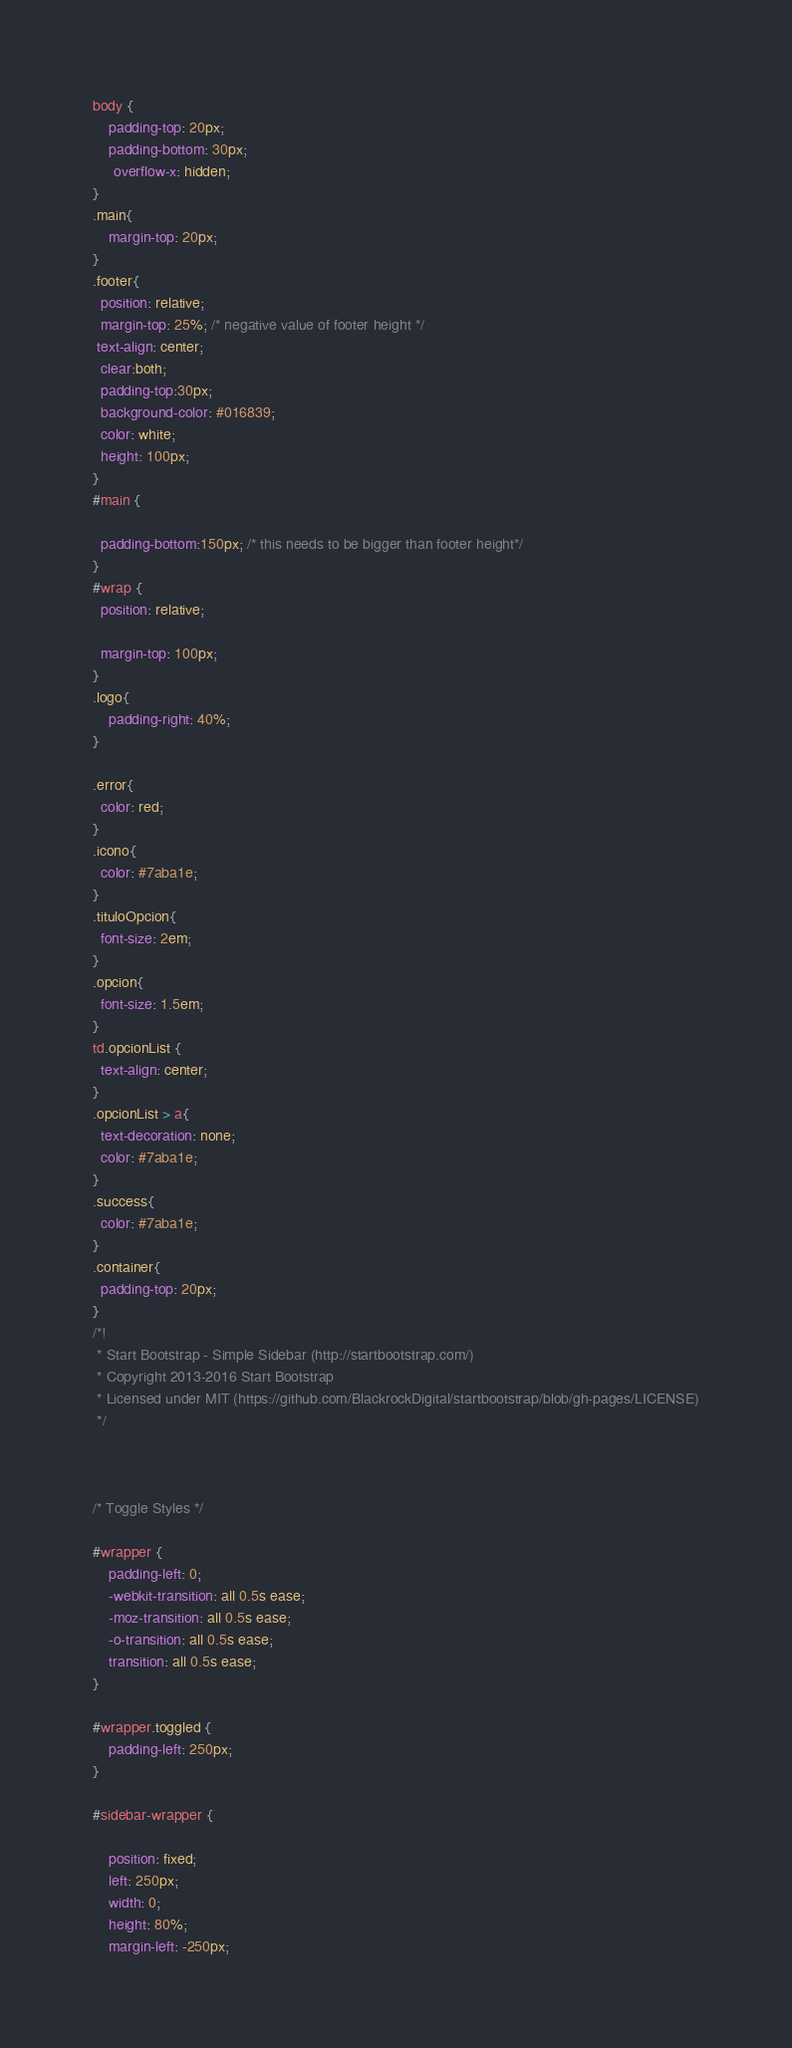<code> <loc_0><loc_0><loc_500><loc_500><_CSS_>body {
    padding-top: 20px;
    padding-bottom: 30px;
     overflow-x: hidden;
}
.main{
    margin-top: 20px; 
}
.footer{
  position: relative;
  margin-top: 25%; /* negative value of footer height */
 text-align: center;
  clear:both;
  padding-top:30px;
  background-color: #016839;
  color: white;
  height: 100px;
}
#main {
  
  padding-bottom:150px; /* this needs to be bigger than footer height*/
}
#wrap {
  position: relative;
  
  margin-top: 100px;
}
.logo{
    padding-right: 40%;
}

.error{
  color: red;
}
.icono{
  color: #7aba1e;
}
.tituloOpcion{
  font-size: 2em;
}
.opcion{
  font-size: 1.5em;
}
td.opcionList {
  text-align: center;
}
.opcionList > a{
  text-decoration: none;
  color: #7aba1e;
}
.success{
  color: #7aba1e;
}
.container{
  padding-top: 20px;
}
/*!
 * Start Bootstrap - Simple Sidebar (http://startbootstrap.com/)
 * Copyright 2013-2016 Start Bootstrap
 * Licensed under MIT (https://github.com/BlackrockDigital/startbootstrap/blob/gh-pages/LICENSE)
 */

 

/* Toggle Styles */

#wrapper {
    padding-left: 0;
    -webkit-transition: all 0.5s ease;
    -moz-transition: all 0.5s ease;
    -o-transition: all 0.5s ease;
    transition: all 0.5s ease;
}

#wrapper.toggled {
    padding-left: 250px;
}

#sidebar-wrapper {
   
    position: fixed;
    left: 250px;
    width: 0;
    height: 80%;
    margin-left: -250px;</code> 